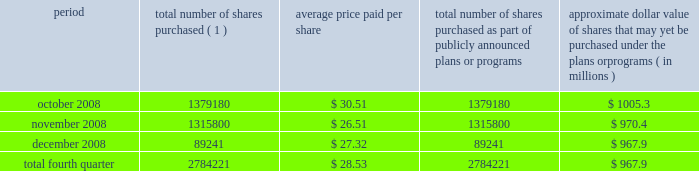Act of 1933 , as amended , and section 1145 of the united states code .
No underwriters were engaged in connection with such issuances .
During the three months ended december 31 , 2008 , we issued an aggregate of 7173456 shares of our common stock upon conversion of $ 147.1 million principal amount of our 3.00% ( 3.00 % ) notes .
Pursuant to the terms of the indenture , holders of the 3.00% ( 3.00 % ) notes receive 48.7805 shares of our common stock for every $ 1000 principal amount of notes converted .
In connection with the conversions , we paid such holders an aggregate of approximately $ 3.7 million , calculated based on the accrued and unpaid interest on the notes and the discounted value of the future interest payments on the notes .
All shares were issued in reliance on the exemption from registration set forth in section 3 ( a ) ( 9 ) of the securities act of 1933 , as amended .
No underwriters were engaged in connection with such issuances .
Issuer purchases of equity securities during the three months ended december 31 , 2008 , we repurchased 2784221 shares of our common stock for an aggregate of $ 79.4 million , including commissions and fees , pursuant to our publicly announced stock repurchase program , as follows : period total number of shares purchased ( 1 ) average price paid per share total number of shares purchased as part of publicly announced plans or programs approximate dollar value of shares that may yet be purchased under the plans or programs ( in millions ) .
( 1 ) repurchases made pursuant to the $ 1.5 billion stock repurchase program approved by our board of directors in february 2008 .
Under this program , our management is authorized to purchase shares from time to time through open market purchases or privately negotiated transactions at prevailing prices as permitted by securities laws and other legal requirements , and subject to market conditions and other factors .
To facilitate repurchases , we make purchases pursuant to a trading plan under rule 10b5-1 of the exchange act , which allows us to repurchase shares during periods when we otherwise might be prevented from doing so under insider trading laws or because of self-imposed trading blackout periods .
This program may be discontinued at any time .
As reflected in the above table , in the fourth quarter of 2008 , we significantly reduced purchases of common stock under our stock repurchase program based on the downturn in the economy and the disruptions in the financial and credit markets .
Subsequent to december 31 , 2008 , we repurchased approximately 28000 shares of our common stock for an aggregate of $ 0.8 million , including commissions and fees , pursuant to this program .
We expect to continue to manage the pacing of the program in the future in response to general market conditions and other relevant factors. .
What is the total cash used for stock repurchase during the fourth quarter of 2008 , in millions? 
Computations: ((2784221 * 28.53) / 1000000)
Answer: 79.43383. 